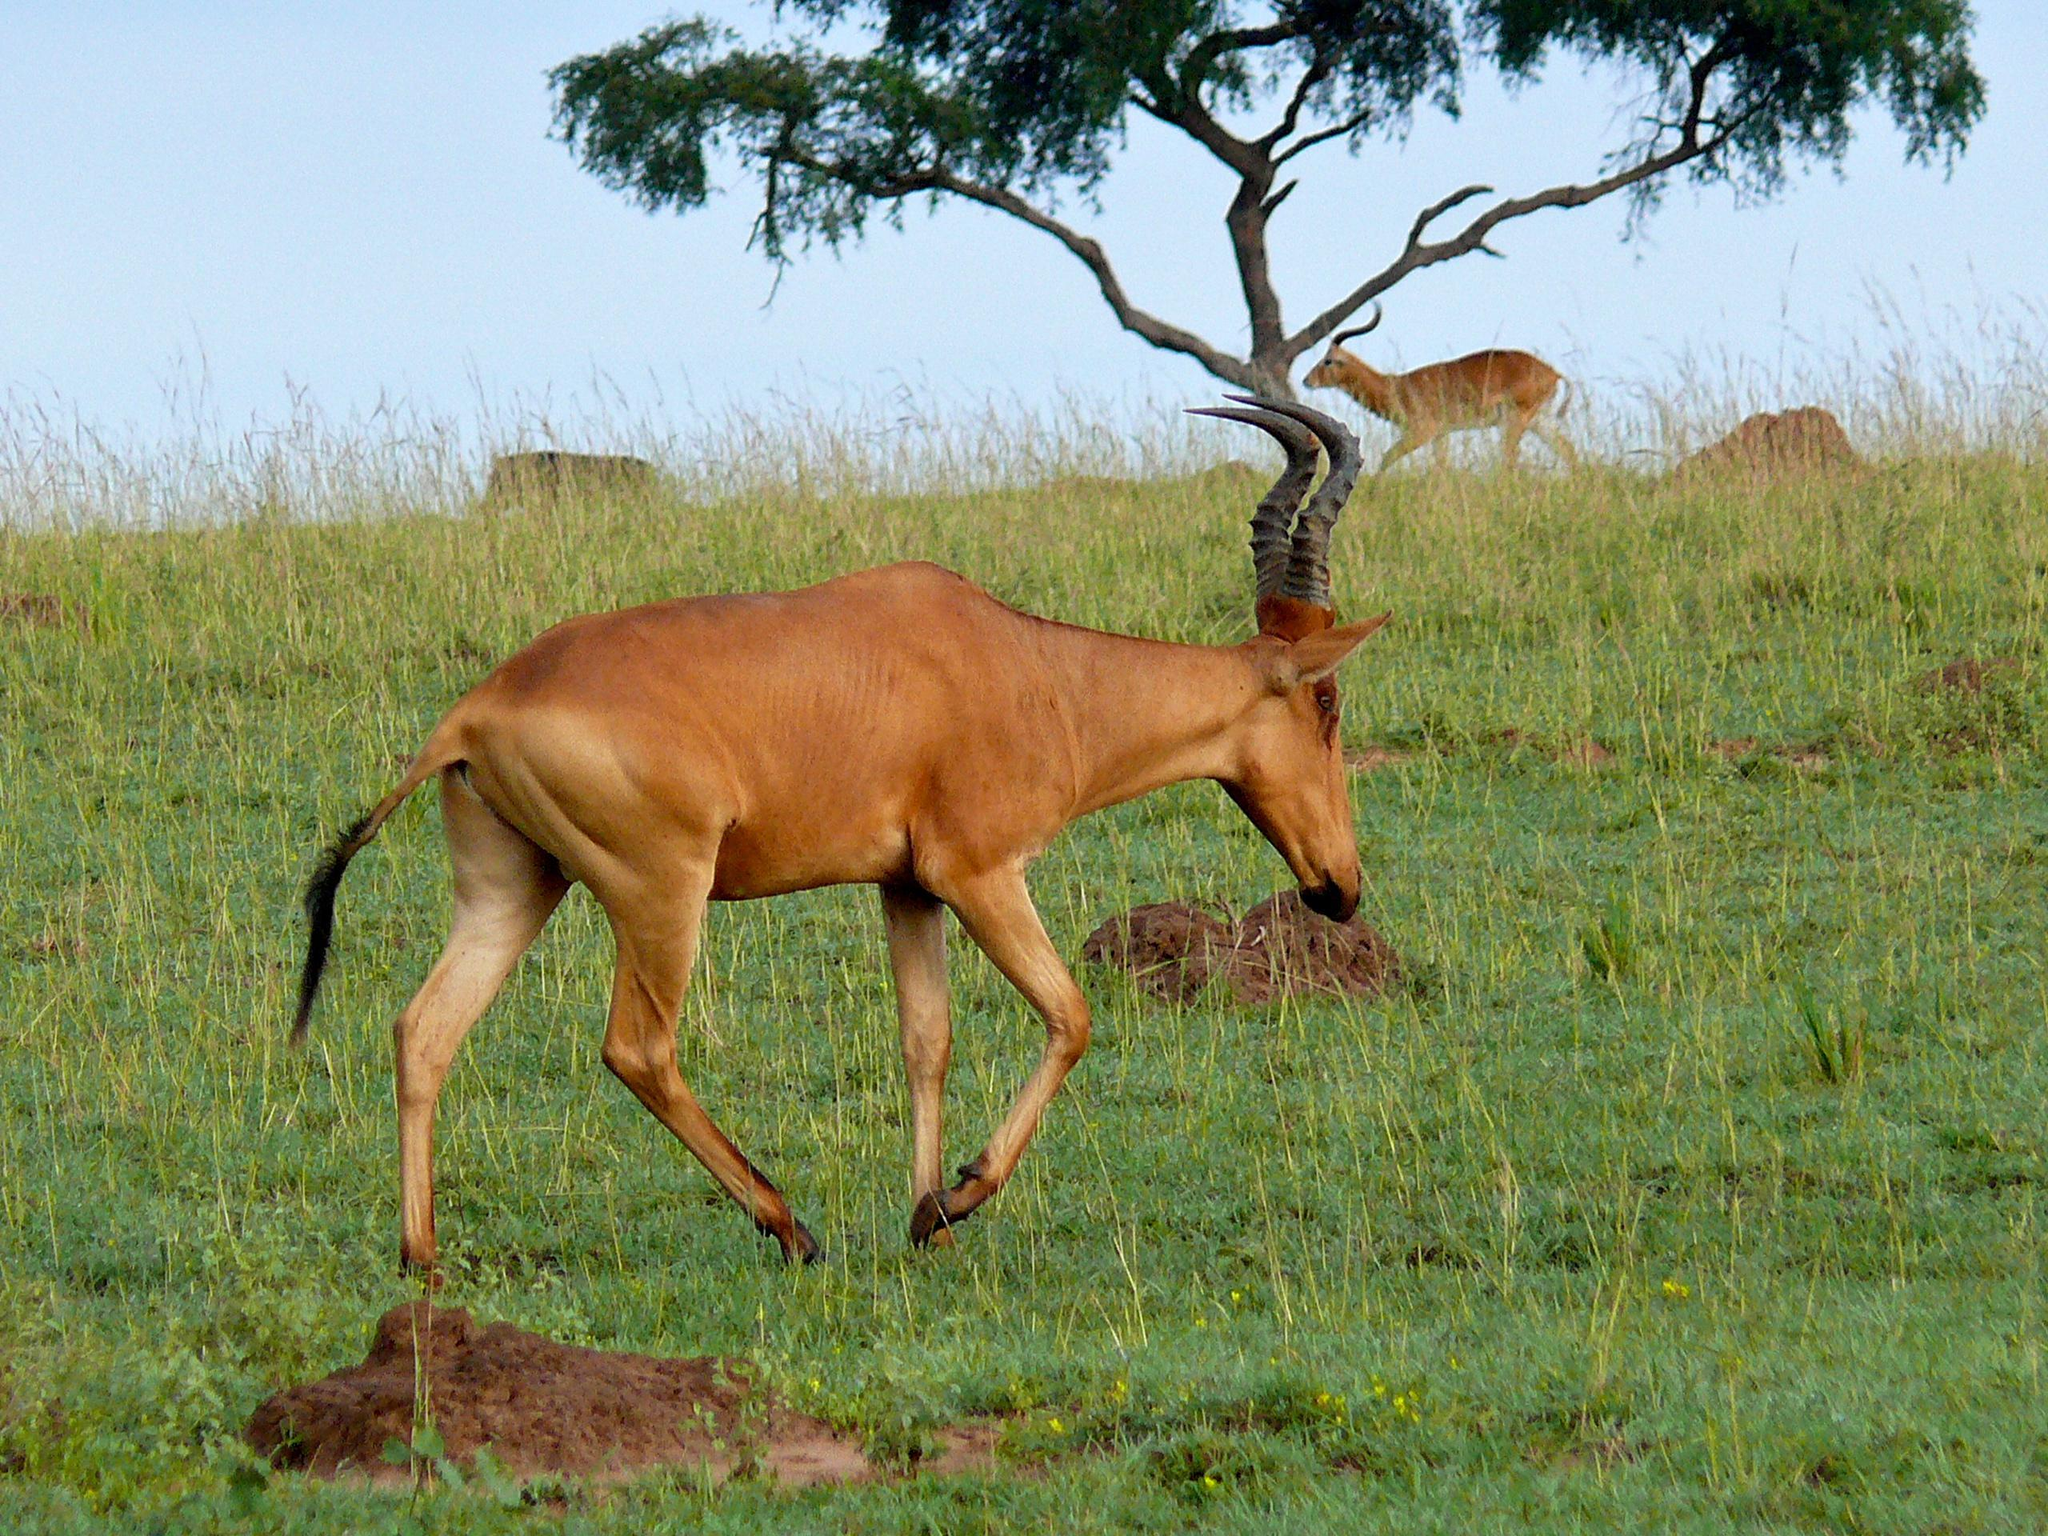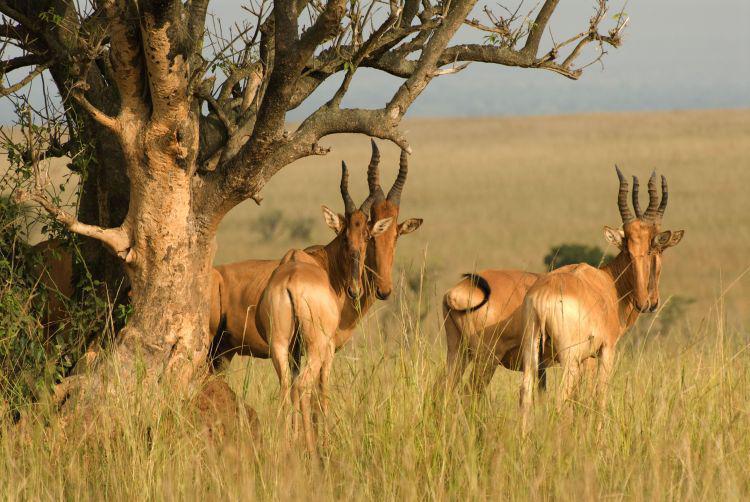The first image is the image on the left, the second image is the image on the right. For the images displayed, is the sentence "An image contains only one horned animal, which is standing with its head and body turned leftward." factually correct? Answer yes or no. No. The first image is the image on the left, the second image is the image on the right. For the images displayed, is the sentence "Two antelopes are facing the opposite direction than the other." factually correct? Answer yes or no. No. 